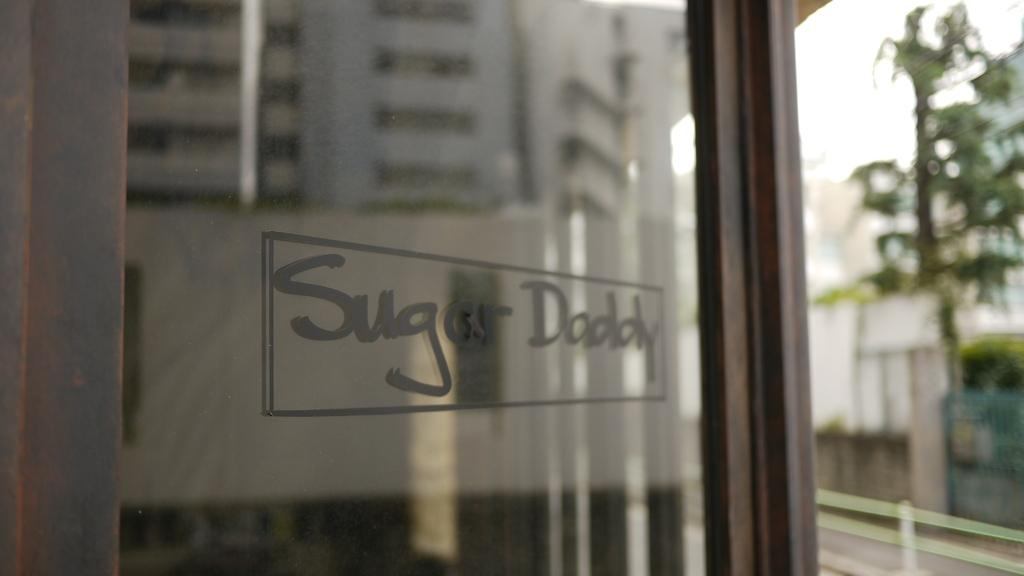What is the overall quality of the image? The image is blurred. What type of object can be seen in the image? There is a glass object in the image. What is written or printed on the glass object? There is text on the glass. What type of natural element is visible in the image? There is a tree visible in the image. What is the color of the sky in the image? The sky appears to be white in the image. How many plants are growing in the crib in the image? There is no crib or plants present in the image. What type of bike is visible in the image? There is no bike present in the image. 